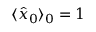<formula> <loc_0><loc_0><loc_500><loc_500>\langle \hat { x } _ { 0 } \rangle _ { 0 } = 1</formula> 